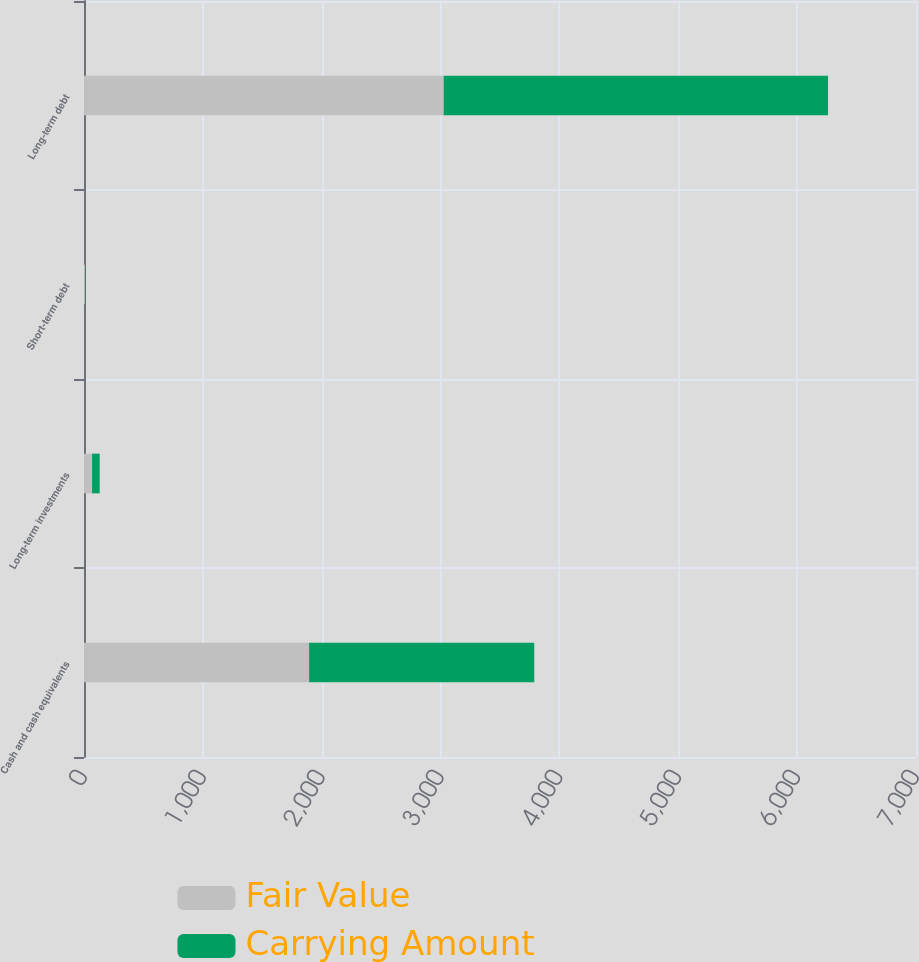Convert chart. <chart><loc_0><loc_0><loc_500><loc_500><stacked_bar_chart><ecel><fcel>Cash and cash equivalents<fcel>Long-term investments<fcel>Short-term debt<fcel>Long-term debt<nl><fcel>Fair Value<fcel>1894<fcel>68<fcel>8<fcel>3026<nl><fcel>Carrying Amount<fcel>1894<fcel>64<fcel>8<fcel>3234<nl></chart> 